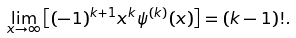<formula> <loc_0><loc_0><loc_500><loc_500>\lim _ { x \to \infty } \left [ ( - 1 ) ^ { k + 1 } x ^ { k } \psi ^ { ( k ) } ( x ) \right ] = ( k - 1 ) ! .</formula> 